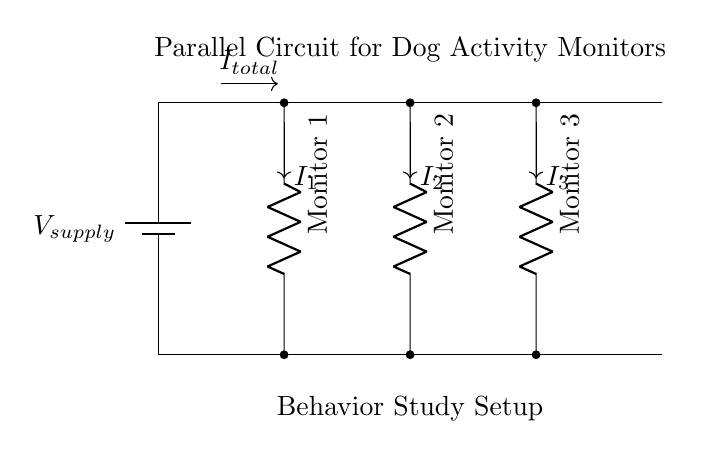What is the type of circuit depicted? The diagram clearly illustrates a parallel circuit setup, indicated by the multiple branches connected to the same voltage source. Each monitor is independently connected to the supply, characteristic of parallel circuits.
Answer: Parallel How many dog activity monitors are shown? The circuit shows three branches leading to three distinct activity monitors, each represented as a resistor in the diagram. This detail confirms that there are three separate devices.
Answer: Three What is the total current directed from the supply? The total current is represented as I total in the diagram, shown flowing into the main branches where it splits toward the monitors. While specific values are not provided, it is clear that it represents the sum of the individual currents.
Answer: I total Which monitor is connected to the second branch? The monitor connected to the second branch, identified by the horizontal position at four units along the x-axis, is labeled as Monitor 2. It is positioned directly over the second vertical path connected to the supply.
Answer: Monitor 2 If each monitor consumes a current of one amp, what would be the total current supplied? The total current in a parallel circuit is the sum of the currents through each branch. Given all three monitors consume one amp, the total current would be the sum: one amp plus one amp plus one amp equals three amps.
Answer: Three amps What represents the voltage supply in the circuit? The voltage supply is denoted as V supply at the top of the circuit, connected to the parallel branches. This labeling indicates the total potential difference delivered to the circuit components.
Answer: V supply What does the absence of any other components indicate about this setup? The lack of additional elements means the circuit is straightforward, focusing only on the monitors and the necessary connections to the power source, which signifies that it is designed for simple measurements in this behavior study.
Answer: Simplicity 